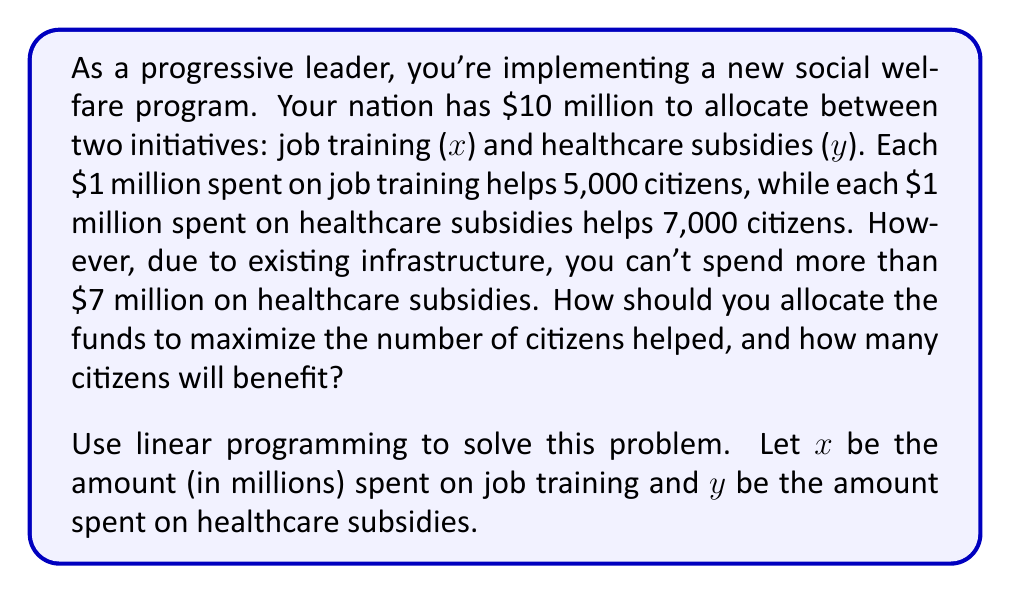Could you help me with this problem? 1) First, let's define our objective function. We want to maximize the number of citizens helped:
   Maximize: $5000x + 7000y$

2) Now, let's list our constraints:
   a) Total budget: $x + y \leq 10$
   b) Healthcare subsidy limit: $y \leq 7$
   c) Non-negativity: $x \geq 0, y \geq 0$

3) To solve this, we'll use the corner point method. The feasible region is bounded by:
   $x + y = 10$
   $y = 7$
   $x = 0$
   $y = 0$

4) The corner points are:
   (0, 0), (0, 7), (3, 7), (10, 0)

5) Let's evaluate our objective function at each point:
   (0, 0): $5000(0) + 7000(0) = 0$
   (0, 7): $5000(0) + 7000(7) = 49,000$
   (3, 7): $5000(3) + 7000(7) = 64,000$
   (10, 0): $5000(10) + 7000(0) = 50,000$

6) The maximum value occurs at (3, 7), so we should allocate:
   $3 million to job training
   $7 million to healthcare subsidies

7) This will help 64,000 citizens in total.
Answer: $3 million on job training, $7 million on healthcare subsidies; 64,000 citizens helped 